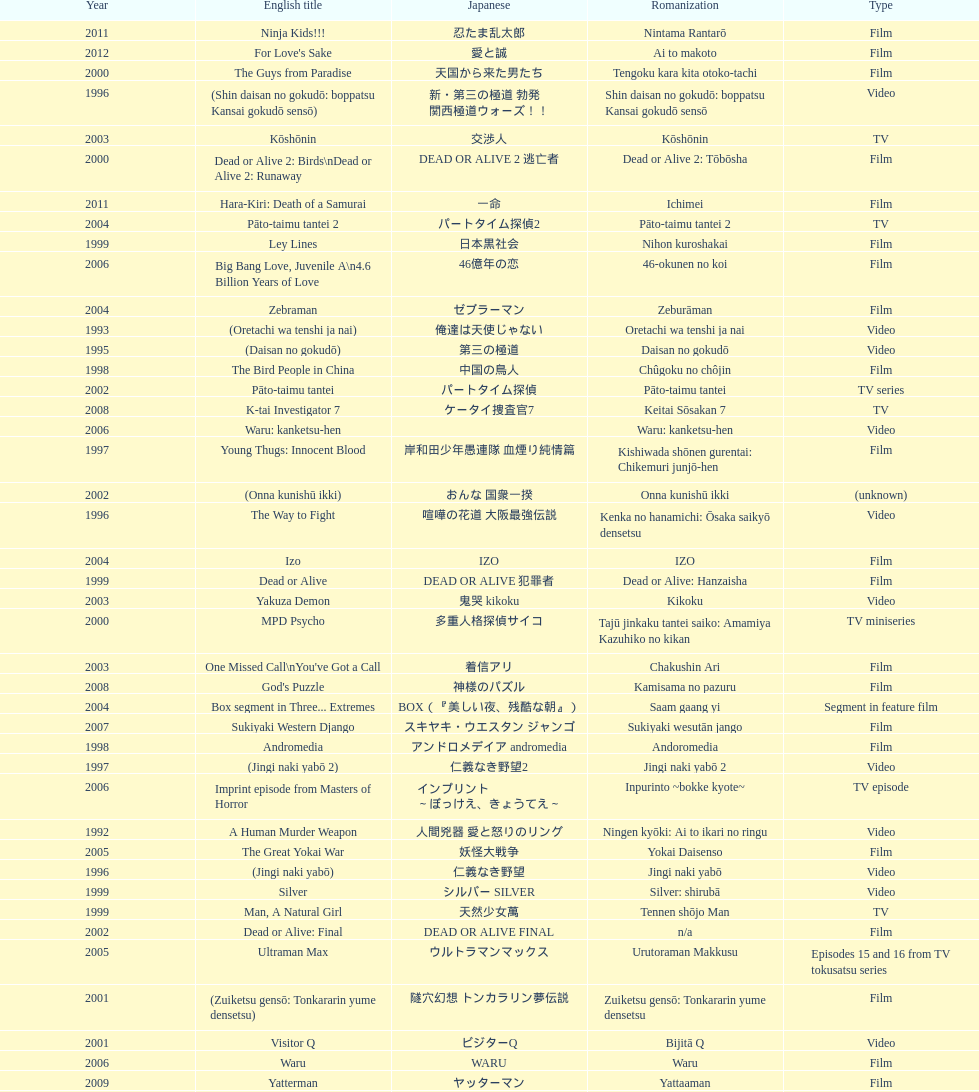Would you mind parsing the complete table? {'header': ['Year', 'English title', 'Japanese', 'Romanization', 'Type'], 'rows': [['2011', 'Ninja Kids!!!', '忍たま乱太郎', 'Nintama Rantarō', 'Film'], ['2012', "For Love's Sake", '愛と誠', 'Ai to makoto', 'Film'], ['2000', 'The Guys from Paradise', '天国から来た男たち', 'Tengoku kara kita otoko-tachi', 'Film'], ['1996', '(Shin daisan no gokudō: boppatsu Kansai gokudō sensō)', '新・第三の極道 勃発 関西極道ウォーズ！！', 'Shin daisan no gokudō: boppatsu Kansai gokudō sensō', 'Video'], ['2003', 'Kōshōnin', '交渉人', 'Kōshōnin', 'TV'], ['2000', 'Dead or Alive 2: Birds\\nDead or Alive 2: Runaway', 'DEAD OR ALIVE 2 逃亡者', 'Dead or Alive 2: Tōbōsha', 'Film'], ['2011', 'Hara-Kiri: Death of a Samurai', '一命', 'Ichimei', 'Film'], ['2004', 'Pāto-taimu tantei 2', 'パートタイム探偵2', 'Pāto-taimu tantei 2', 'TV'], ['1999', 'Ley Lines', '日本黒社会', 'Nihon kuroshakai', 'Film'], ['2006', 'Big Bang Love, Juvenile A\\n4.6 Billion Years of Love', '46億年の恋', '46-okunen no koi', 'Film'], ['2004', 'Zebraman', 'ゼブラーマン', 'Zeburāman', 'Film'], ['1993', '(Oretachi wa tenshi ja nai)', '俺達は天使じゃない', 'Oretachi wa tenshi ja nai', 'Video'], ['1995', '(Daisan no gokudō)', '第三の極道', 'Daisan no gokudō', 'Video'], ['1998', 'The Bird People in China', '中国の鳥人', 'Chûgoku no chôjin', 'Film'], ['2002', 'Pāto-taimu tantei', 'パートタイム探偵', 'Pāto-taimu tantei', 'TV series'], ['2008', 'K-tai Investigator 7', 'ケータイ捜査官7', 'Keitai Sōsakan 7', 'TV'], ['2006', 'Waru: kanketsu-hen', '', 'Waru: kanketsu-hen', 'Video'], ['1997', 'Young Thugs: Innocent Blood', '岸和田少年愚連隊 血煙り純情篇', 'Kishiwada shōnen gurentai: Chikemuri junjō-hen', 'Film'], ['2002', '(Onna kunishū ikki)', 'おんな 国衆一揆', 'Onna kunishū ikki', '(unknown)'], ['1996', 'The Way to Fight', '喧嘩の花道 大阪最強伝説', 'Kenka no hanamichi: Ōsaka saikyō densetsu', 'Video'], ['2004', 'Izo', 'IZO', 'IZO', 'Film'], ['1999', 'Dead or Alive', 'DEAD OR ALIVE 犯罪者', 'Dead or Alive: Hanzaisha', 'Film'], ['2003', 'Yakuza Demon', '鬼哭 kikoku', 'Kikoku', 'Video'], ['2000', 'MPD Psycho', '多重人格探偵サイコ', 'Tajū jinkaku tantei saiko: Amamiya Kazuhiko no kikan', 'TV miniseries'], ['2003', "One Missed Call\\nYou've Got a Call", '着信アリ', 'Chakushin Ari', 'Film'], ['2008', "God's Puzzle", '神様のパズル', 'Kamisama no pazuru', 'Film'], ['2004', 'Box segment in Three... Extremes', 'BOX（『美しい夜、残酷な朝』）', 'Saam gaang yi', 'Segment in feature film'], ['2007', 'Sukiyaki Western Django', 'スキヤキ・ウエスタン ジャンゴ', 'Sukiyaki wesutān jango', 'Film'], ['1998', 'Andromedia', 'アンドロメデイア andromedia', 'Andoromedia', 'Film'], ['1997', '(Jingi naki yabō 2)', '仁義なき野望2', 'Jingi naki yabō 2', 'Video'], ['2006', 'Imprint episode from Masters of Horror', 'インプリント ～ぼっけえ、きょうてえ～', 'Inpurinto ~bokke kyote~', 'TV episode'], ['1992', 'A Human Murder Weapon', '人間兇器 愛と怒りのリング', 'Ningen kyōki: Ai to ikari no ringu', 'Video'], ['2005', 'The Great Yokai War', '妖怪大戦争', 'Yokai Daisenso', 'Film'], ['1996', '(Jingi naki yabō)', '仁義なき野望', 'Jingi naki yabō', 'Video'], ['1999', 'Silver', 'シルバー SILVER', 'Silver: shirubā', 'Video'], ['1999', 'Man, A Natural Girl', '天然少女萬', 'Tennen shōjo Man', 'TV'], ['2002', 'Dead or Alive: Final', 'DEAD OR ALIVE FINAL', 'n/a', 'Film'], ['2005', 'Ultraman Max', 'ウルトラマンマックス', 'Urutoraman Makkusu', 'Episodes 15 and 16 from TV tokusatsu series'], ['2001', '(Zuiketsu gensō: Tonkararin yume densetsu)', '隧穴幻想 トンカラリン夢伝説', 'Zuiketsu gensō: Tonkararin yume densetsu', 'Film'], ['2001', 'Visitor Q', 'ビジターQ', 'Bijitā Q', 'Video'], ['2006', 'Waru', 'WARU', 'Waru', 'Film'], ['2009', 'Yatterman', 'ヤッターマン', 'Yattaaman', 'Film'], ['2010', 'Thirteen Assassins', '十三人の刺客', 'Jûsan-nin no shikaku', 'Film'], ['2001', 'Family', 'FAMILY', 'n/a', 'Film'], ['1994', '(Shura no mokushiroku: Bodigādo Kiba)', '修羅の黙示録 ボディーガード牙', 'Shura no mokushiroku: Bodigādo Kiba', 'Video'], ['2007', 'Zatoichi', '座頭市', 'Zatōichi', 'Stageplay'], ['2010', 'Zebraman 2: Attack on Zebra City', 'ゼブラーマン -ゼブラシティの逆襲', 'Zeburāman -Zebura Shiti no Gyakushū', 'Film'], ['2012', 'Lesson of the Evil', '悪の教典', 'Aku no Kyōten', 'Film'], ['2001', '(Kikuchi-jō monogatari: sakimori-tachi no uta)', '鞠智城物語 防人たちの唄', 'Kikuchi-jō monogatari: sakimori-tachi no uta', 'Film'], ['1995', 'Osaka Tough Guys', 'なにわ遊侠伝', 'Naniwa yūkyōden', 'Video'], ['2002', 'Shangri-La', '金融破滅ニッポン 桃源郷の人々', "Kin'yū hametsu Nippon: Tōgenkyō no hito-bito", 'Film'], ['1996', '(Shin daisan no gokudō II)', '新・第三の極道II', 'Shin daisan no gokudō II', 'Video'], ['2001', 'The Happiness of the Katakuris', 'カタクリ家の幸福', 'Katakuri-ke no kōfuku', 'Film'], ['1996', 'Fudoh: The New Generation', '極道戦国志 不動', 'Gokudō sengokushi: Fudō', 'Film'], ['1999', 'Audition', 'オーディション', 'Ōdishon', 'Film'], ['1991', '(Shissō Feraari 250 GTO / Rasuto ran: Ai to uragiri no hyaku-oku en)', '疾走フェラーリ250GTO/ラスト・ラン～愛と裏切りの百億円', 'Shissō Feraari 250 GTO / Rasuto ran: Ai to uragiri no hyaku-oku en\\nShissō Feraari 250 GTO / Rasuto ran: Ai to uragiri no ¥10 000 000 000', 'TV'], ['2002', 'Graveyard of Honor', '新・仁義の墓場', 'Shin jingi no hakaba', 'Film'], ['1991', '(Redi hantā: Koroshi no pureryuudo)', 'レディハンター 殺しのプレュード', 'Redi hantā: Koroshi no pureryūdo', 'Video'], ['2007', 'Like a Dragon', '龍が如く 劇場版', 'Ryu ga Gotoku Gekijōban', 'Film'], ['2002', 'Pandōra', 'パンドーラ', 'Pandōra', 'Music video'], ['2002', 'Sabu', 'SABU さぶ', 'Sabu', 'TV'], ['2007', 'Crows Zero', 'クローズZERO', 'Kurōzu Zero', 'Film'], ['1994', 'Shinjuku Outlaw', '新宿アウトロー', 'Shinjuku autorou', 'Video'], ['2003', 'Gozu', '極道恐怖大劇場 牛頭 GOZU', 'Gokudō kyōfu dai-gekijō: Gozu', 'Film'], ['1993', '(Oretachi wa tenshi ja nai 2)', '俺達は天使じゃない２', 'Oretachi wa tenshi ja nai 2', 'Video'], ['1995', '(Shura no mokushiroku 2: Bodigādo Kiba)', '修羅の黙示録2 ボディーガード牙', 'Shura no mokushiroku 2: Bodigādo Kiba', 'Video'], ['2002', 'Deadly Outlaw: Rekka\\nViolent Fire', '実録・安藤昇侠道（アウトロー）伝 烈火', 'Jitsuroku Andō Noboru kyōdō-den: Rekka', 'Film'], ['1993', 'Bodyguard Kiba', 'ボディガード牙', 'Bodigādo Kiba', 'Video'], ['1999', 'Man, Next Natural Girl: 100 Nights In Yokohama\\nN-Girls vs Vampire', '天然少女萬NEXT 横浜百夜篇', 'Tennen shōjo Man next: Yokohama hyaku-ya hen', 'TV'], ['1998', 'Young Thugs: Nostalgia', '岸和田少年愚連隊 望郷', 'Kishiwada shōnen gurentai: Bōkyō', 'Film'], ['2001', 'Ichi the Killer', '殺し屋1', 'Koroshiya 1', 'Film'], ['1997', 'Rainy Dog', '極道黒社会 RAINY DOG', 'Gokudō kuroshakai', 'Film'], ['1996', '(Piinattsu: Rakkasei)', 'ピイナッツ 落華星', 'Piinattsu: Rakkasei', 'Video'], ['2007', 'Detective Story', '探偵物語', 'Tantei monogatari', 'Film'], ['2013', 'Shield of Straw', '藁の楯', 'Wara no Tate', 'Film'], ['1998', 'Blues Harp', 'BLUES HARP', 'n/a', 'Film'], ['2000', "The Making of 'Gemini'", '(unknown)', "Tsukamoto Shin'ya ga Ranpo suru", 'TV documentary'], ['2000', 'The City of Lost Souls\\nThe City of Strangers\\nThe Hazard City', '漂流街 THE HAZARD CITY', 'Hyōryū-gai', 'Film'], ['2012', 'Ace Attorney', '逆転裁判', 'Gyakuten Saiban', 'Film'], ['1997', 'Full Metal Yakuza', 'FULL METAL 極道', 'Full Metal gokudō', 'Video'], ['1995', 'Shinjuku Triad Society', '新宿黒社会 チャイナ マフィア戦争', 'Shinjuku kuroshakai: Chaina mafia sensō', 'Film'], ['2001', 'Agitator', '荒ぶる魂たち', 'Araburu tamashii-tachi', 'Film'], ['2006', 'Sun Scarred', '太陽の傷', 'Taiyo no kizu', 'Film'], ['2009', 'Crows Zero 2', 'クローズZERO 2', 'Kurōzu Zero 2', 'Film'], ['2013', 'The Mole Song: Undercover Agent Reiji', '土竜の唄\u3000潜入捜査官 REIJI', 'Mogura no uta – sennyu sosakan: Reiji', 'Film'], ['1999', 'Salaryman Kintaro\\nWhite Collar Worker Kintaro', 'サラリーマン金太郎', 'Sarariiman Kintarō', 'Film'], ['2003', 'The Man in White', '許されざる者', 'Yurusarezaru mono', 'Film'], ['1991', '(Toppū! Minipato tai - Aikyacchi Jankushon)', '突風！ ミニパト隊 アイキャッチ・ジャンクション', 'Toppū! Minipato tai - Aikyatchi Jankushon', 'Video']]} Was shinjuku triad society a film or tv release? Film. 